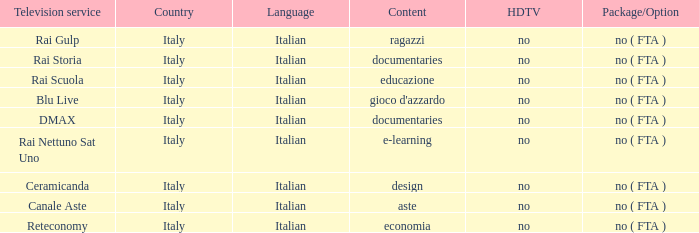What is the Language when the Reteconomy is the television service? Italian. Could you parse the entire table? {'header': ['Television service', 'Country', 'Language', 'Content', 'HDTV', 'Package/Option'], 'rows': [['Rai Gulp', 'Italy', 'Italian', 'ragazzi', 'no', 'no ( FTA )'], ['Rai Storia', 'Italy', 'Italian', 'documentaries', 'no', 'no ( FTA )'], ['Rai Scuola', 'Italy', 'Italian', 'educazione', 'no', 'no ( FTA )'], ['Blu Live', 'Italy', 'Italian', "gioco d'azzardo", 'no', 'no ( FTA )'], ['DMAX', 'Italy', 'Italian', 'documentaries', 'no', 'no ( FTA )'], ['Rai Nettuno Sat Uno', 'Italy', 'Italian', 'e-learning', 'no', 'no ( FTA )'], ['Ceramicanda', 'Italy', 'Italian', 'design', 'no', 'no ( FTA )'], ['Canale Aste', 'Italy', 'Italian', 'aste', 'no', 'no ( FTA )'], ['Reteconomy', 'Italy', 'Italian', 'economia', 'no', 'no ( FTA )']]} 